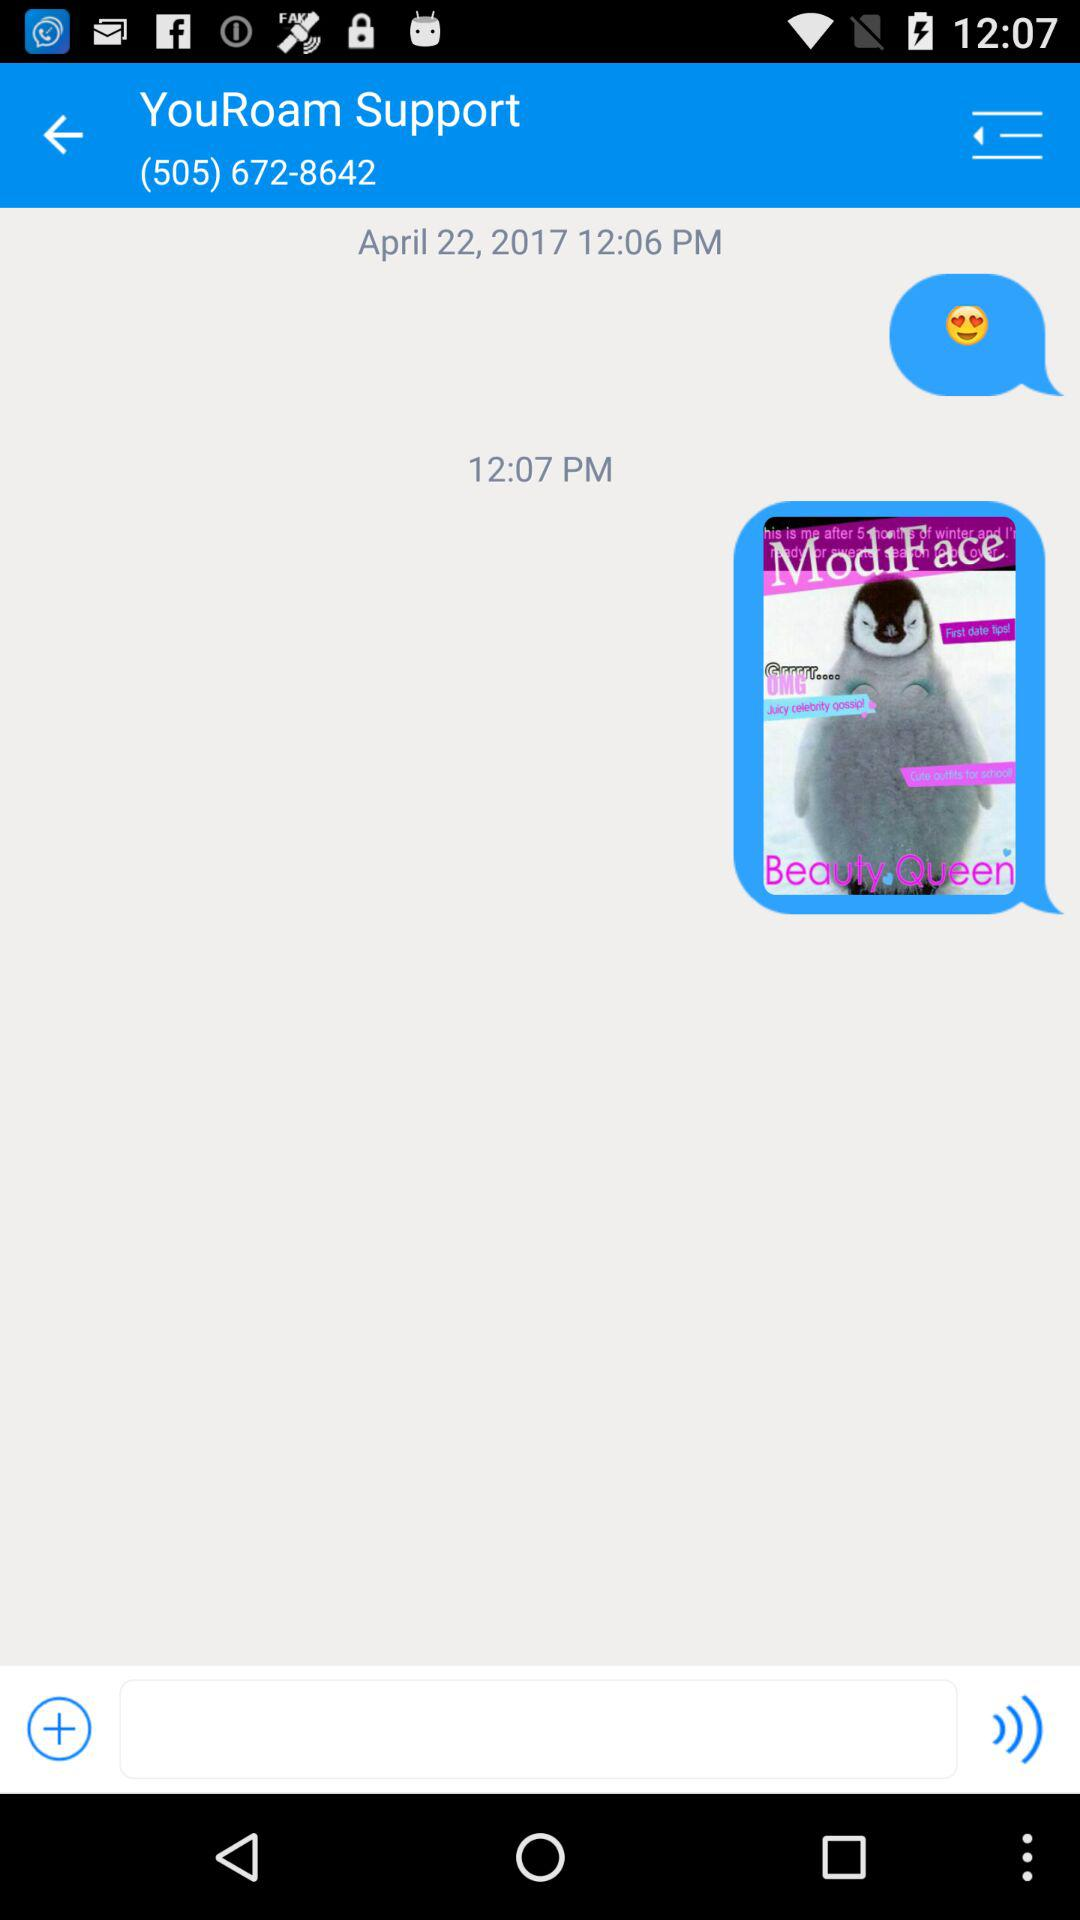How many minutes apart are the two timestamps?
Answer the question using a single word or phrase. 1 